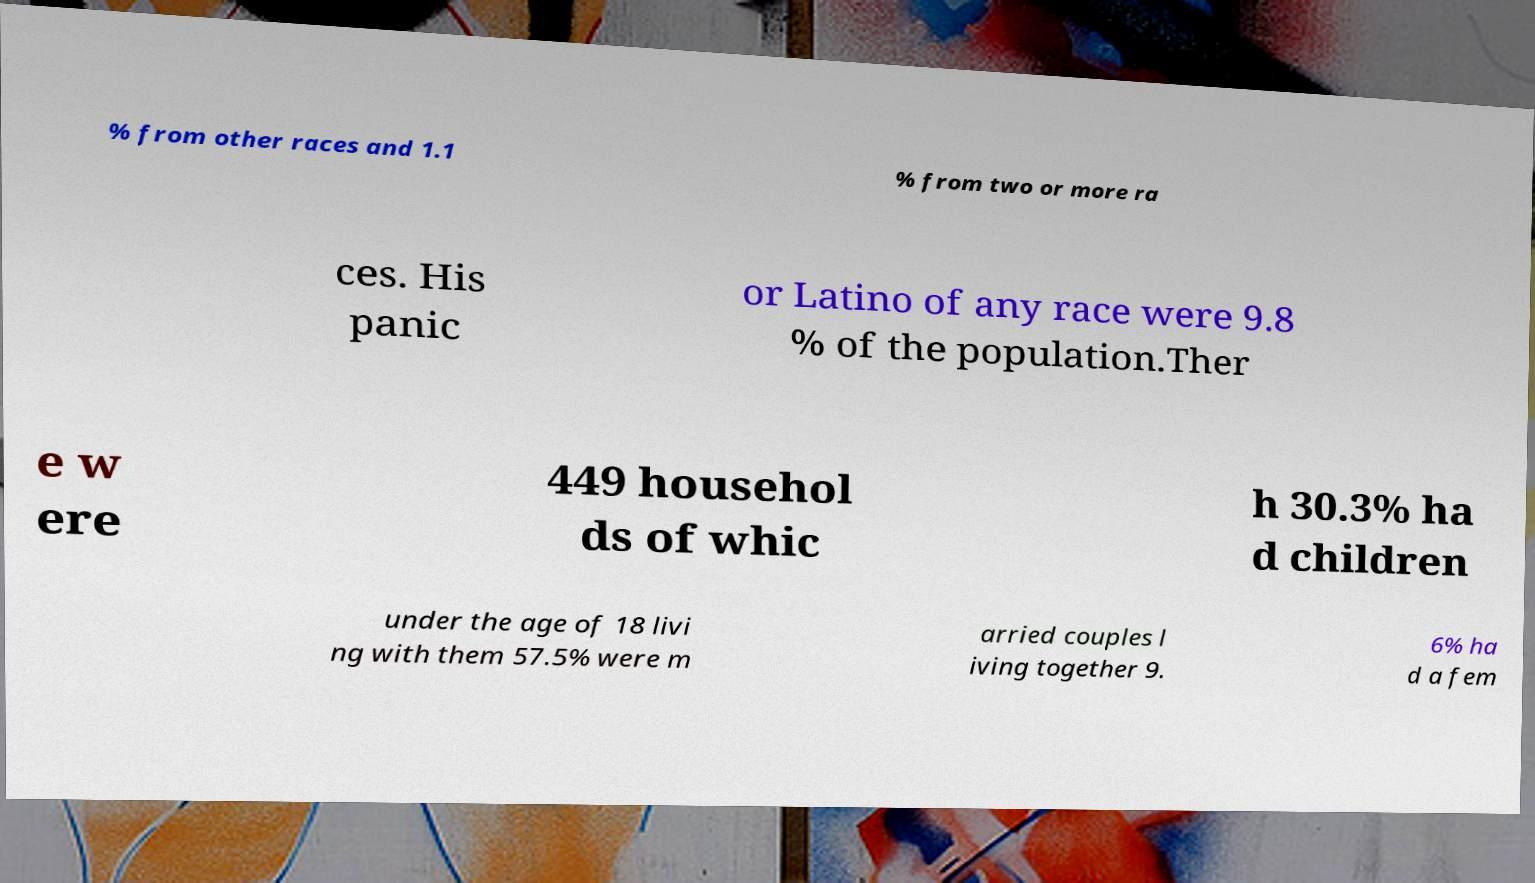Please read and relay the text visible in this image. What does it say? % from other races and 1.1 % from two or more ra ces. His panic or Latino of any race were 9.8 % of the population.Ther e w ere 449 househol ds of whic h 30.3% ha d children under the age of 18 livi ng with them 57.5% were m arried couples l iving together 9. 6% ha d a fem 